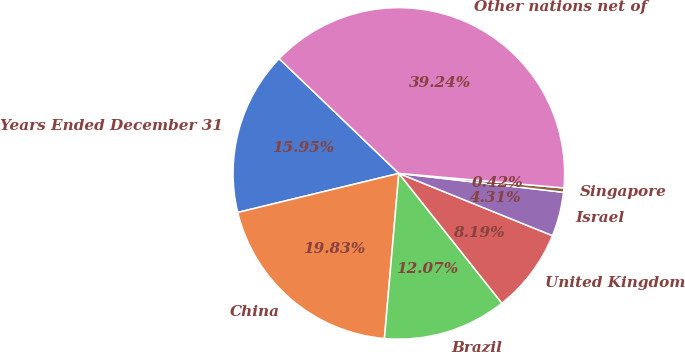Convert chart. <chart><loc_0><loc_0><loc_500><loc_500><pie_chart><fcel>Years Ended December 31<fcel>China<fcel>Brazil<fcel>United Kingdom<fcel>Israel<fcel>Singapore<fcel>Other nations net of<nl><fcel>15.95%<fcel>19.83%<fcel>12.07%<fcel>8.19%<fcel>4.31%<fcel>0.42%<fcel>39.24%<nl></chart> 